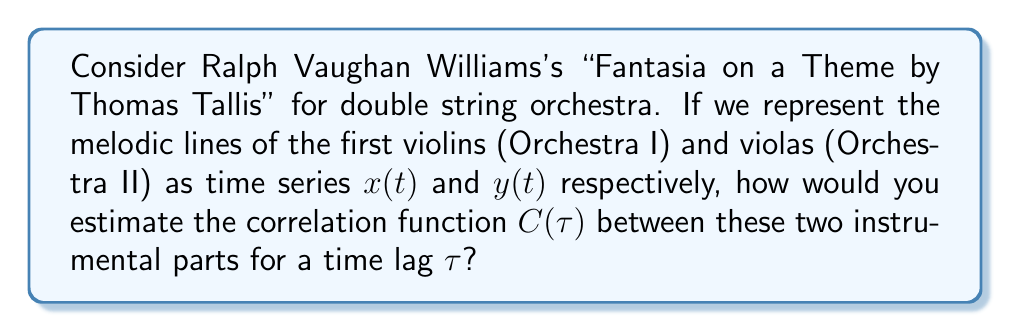Help me with this question. To estimate the correlation function between the two instrumental parts, we can follow these steps:

1. Define the correlation function:
   The correlation function $C(\tau)$ between two time series $x(t)$ and $y(t)$ is given by:

   $$C(\tau) = \frac{\langle (x(t) - \langle x \rangle)(y(t+\tau) - \langle y \rangle) \rangle}{\sigma_x \sigma_y}$$

   where $\langle \cdot \rangle$ denotes the time average, and $\sigma_x$ and $\sigma_y$ are the standard deviations of $x(t)$ and $y(t)$ respectively.

2. Discretize the time series:
   Since musical scores are typically discrete in nature, we can represent the melodic lines as discrete time series $x_i$ and $y_i$, where $i = 1, 2, ..., N$, and $N$ is the total number of time steps (e.g., beats or measures) in the piece.

3. Calculate means and standard deviations:
   $$\langle x \rangle = \frac{1}{N} \sum_{i=1}^N x_i$$
   $$\langle y \rangle = \frac{1}{N} \sum_{i=1}^N y_i$$
   $$\sigma_x = \sqrt{\frac{1}{N} \sum_{i=1}^N (x_i - \langle x \rangle)^2}$$
   $$\sigma_y = \sqrt{\frac{1}{N} \sum_{i=1}^N (y_i - \langle y \rangle)^2}$$

4. Estimate the correlation function:
   For a given time lag $k$, we can estimate $C(k)$ as:

   $$C(k) = \frac{1}{(N-k)\sigma_x \sigma_y} \sum_{i=1}^{N-k} (x_i - \langle x \rangle)(y_{i+k} - \langle y \rangle)$$

   where $k = 0, 1, 2, ..., K$, and $K$ is the maximum lag we want to consider.

5. Interpret the results:
   - $C(k) = 1$ indicates perfect positive correlation at lag $k$
   - $C(k) = -1$ indicates perfect negative correlation at lag $k$
   - $C(k) = 0$ indicates no correlation at lag $k$

By calculating $C(k)$ for various lags, we can analyze how the correlation between the first violins and violas changes throughout the piece, potentially revealing structural elements of Vaughan Williams's composition.
Answer: $C(k) = \frac{1}{(N-k)\sigma_x \sigma_y} \sum_{i=1}^{N-k} (x_i - \langle x \rangle)(y_{i+k} - \langle y \rangle)$ 